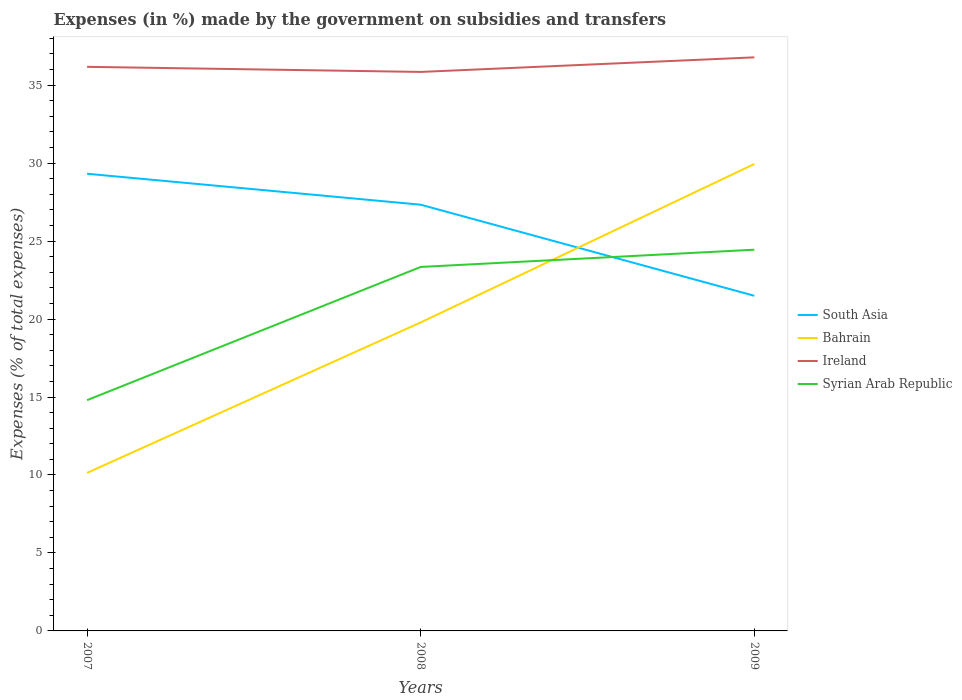Does the line corresponding to Ireland intersect with the line corresponding to South Asia?
Your response must be concise. No. Across all years, what is the maximum percentage of expenses made by the government on subsidies and transfers in Bahrain?
Make the answer very short. 10.14. In which year was the percentage of expenses made by the government on subsidies and transfers in Syrian Arab Republic maximum?
Your answer should be compact. 2007. What is the total percentage of expenses made by the government on subsidies and transfers in South Asia in the graph?
Your answer should be compact. 1.98. What is the difference between the highest and the second highest percentage of expenses made by the government on subsidies and transfers in Ireland?
Provide a short and direct response. 0.93. What is the difference between the highest and the lowest percentage of expenses made by the government on subsidies and transfers in Syrian Arab Republic?
Keep it short and to the point. 2. How many years are there in the graph?
Provide a succinct answer. 3. What is the difference between two consecutive major ticks on the Y-axis?
Your response must be concise. 5. Does the graph contain any zero values?
Your answer should be compact. No. How many legend labels are there?
Ensure brevity in your answer.  4. How are the legend labels stacked?
Provide a succinct answer. Vertical. What is the title of the graph?
Make the answer very short. Expenses (in %) made by the government on subsidies and transfers. Does "Dominican Republic" appear as one of the legend labels in the graph?
Keep it short and to the point. No. What is the label or title of the Y-axis?
Provide a short and direct response. Expenses (% of total expenses). What is the Expenses (% of total expenses) in South Asia in 2007?
Keep it short and to the point. 29.32. What is the Expenses (% of total expenses) of Bahrain in 2007?
Give a very brief answer. 10.14. What is the Expenses (% of total expenses) of Ireland in 2007?
Keep it short and to the point. 36.18. What is the Expenses (% of total expenses) in Syrian Arab Republic in 2007?
Provide a short and direct response. 14.8. What is the Expenses (% of total expenses) of South Asia in 2008?
Provide a short and direct response. 27.33. What is the Expenses (% of total expenses) in Bahrain in 2008?
Keep it short and to the point. 19.78. What is the Expenses (% of total expenses) of Ireland in 2008?
Make the answer very short. 35.85. What is the Expenses (% of total expenses) in Syrian Arab Republic in 2008?
Your response must be concise. 23.34. What is the Expenses (% of total expenses) of South Asia in 2009?
Offer a terse response. 21.49. What is the Expenses (% of total expenses) in Bahrain in 2009?
Give a very brief answer. 29.94. What is the Expenses (% of total expenses) of Ireland in 2009?
Your answer should be compact. 36.78. What is the Expenses (% of total expenses) in Syrian Arab Republic in 2009?
Your response must be concise. 24.45. Across all years, what is the maximum Expenses (% of total expenses) in South Asia?
Keep it short and to the point. 29.32. Across all years, what is the maximum Expenses (% of total expenses) of Bahrain?
Offer a terse response. 29.94. Across all years, what is the maximum Expenses (% of total expenses) of Ireland?
Your answer should be very brief. 36.78. Across all years, what is the maximum Expenses (% of total expenses) in Syrian Arab Republic?
Make the answer very short. 24.45. Across all years, what is the minimum Expenses (% of total expenses) in South Asia?
Provide a short and direct response. 21.49. Across all years, what is the minimum Expenses (% of total expenses) in Bahrain?
Provide a succinct answer. 10.14. Across all years, what is the minimum Expenses (% of total expenses) in Ireland?
Offer a very short reply. 35.85. Across all years, what is the minimum Expenses (% of total expenses) in Syrian Arab Republic?
Your answer should be very brief. 14.8. What is the total Expenses (% of total expenses) of South Asia in the graph?
Offer a terse response. 78.15. What is the total Expenses (% of total expenses) in Bahrain in the graph?
Your response must be concise. 59.87. What is the total Expenses (% of total expenses) of Ireland in the graph?
Offer a terse response. 108.81. What is the total Expenses (% of total expenses) in Syrian Arab Republic in the graph?
Your answer should be compact. 62.59. What is the difference between the Expenses (% of total expenses) of South Asia in 2007 and that in 2008?
Offer a terse response. 1.98. What is the difference between the Expenses (% of total expenses) of Bahrain in 2007 and that in 2008?
Give a very brief answer. -9.65. What is the difference between the Expenses (% of total expenses) in Ireland in 2007 and that in 2008?
Ensure brevity in your answer.  0.33. What is the difference between the Expenses (% of total expenses) of Syrian Arab Republic in 2007 and that in 2008?
Keep it short and to the point. -8.54. What is the difference between the Expenses (% of total expenses) in South Asia in 2007 and that in 2009?
Your response must be concise. 7.83. What is the difference between the Expenses (% of total expenses) of Bahrain in 2007 and that in 2009?
Offer a very short reply. -19.81. What is the difference between the Expenses (% of total expenses) in Ireland in 2007 and that in 2009?
Offer a terse response. -0.61. What is the difference between the Expenses (% of total expenses) of Syrian Arab Republic in 2007 and that in 2009?
Provide a succinct answer. -9.65. What is the difference between the Expenses (% of total expenses) of South Asia in 2008 and that in 2009?
Your answer should be very brief. 5.84. What is the difference between the Expenses (% of total expenses) of Bahrain in 2008 and that in 2009?
Provide a succinct answer. -10.16. What is the difference between the Expenses (% of total expenses) of Ireland in 2008 and that in 2009?
Offer a terse response. -0.93. What is the difference between the Expenses (% of total expenses) of Syrian Arab Republic in 2008 and that in 2009?
Offer a very short reply. -1.11. What is the difference between the Expenses (% of total expenses) of South Asia in 2007 and the Expenses (% of total expenses) of Bahrain in 2008?
Your response must be concise. 9.53. What is the difference between the Expenses (% of total expenses) in South Asia in 2007 and the Expenses (% of total expenses) in Ireland in 2008?
Give a very brief answer. -6.53. What is the difference between the Expenses (% of total expenses) in South Asia in 2007 and the Expenses (% of total expenses) in Syrian Arab Republic in 2008?
Ensure brevity in your answer.  5.98. What is the difference between the Expenses (% of total expenses) of Bahrain in 2007 and the Expenses (% of total expenses) of Ireland in 2008?
Offer a terse response. -25.71. What is the difference between the Expenses (% of total expenses) of Bahrain in 2007 and the Expenses (% of total expenses) of Syrian Arab Republic in 2008?
Your answer should be compact. -13.21. What is the difference between the Expenses (% of total expenses) in Ireland in 2007 and the Expenses (% of total expenses) in Syrian Arab Republic in 2008?
Give a very brief answer. 12.83. What is the difference between the Expenses (% of total expenses) in South Asia in 2007 and the Expenses (% of total expenses) in Bahrain in 2009?
Make the answer very short. -0.62. What is the difference between the Expenses (% of total expenses) in South Asia in 2007 and the Expenses (% of total expenses) in Ireland in 2009?
Offer a terse response. -7.46. What is the difference between the Expenses (% of total expenses) of South Asia in 2007 and the Expenses (% of total expenses) of Syrian Arab Republic in 2009?
Offer a very short reply. 4.87. What is the difference between the Expenses (% of total expenses) in Bahrain in 2007 and the Expenses (% of total expenses) in Ireland in 2009?
Provide a succinct answer. -26.65. What is the difference between the Expenses (% of total expenses) of Bahrain in 2007 and the Expenses (% of total expenses) of Syrian Arab Republic in 2009?
Ensure brevity in your answer.  -14.31. What is the difference between the Expenses (% of total expenses) in Ireland in 2007 and the Expenses (% of total expenses) in Syrian Arab Republic in 2009?
Offer a very short reply. 11.73. What is the difference between the Expenses (% of total expenses) in South Asia in 2008 and the Expenses (% of total expenses) in Bahrain in 2009?
Keep it short and to the point. -2.61. What is the difference between the Expenses (% of total expenses) in South Asia in 2008 and the Expenses (% of total expenses) in Ireland in 2009?
Make the answer very short. -9.45. What is the difference between the Expenses (% of total expenses) in South Asia in 2008 and the Expenses (% of total expenses) in Syrian Arab Republic in 2009?
Offer a very short reply. 2.89. What is the difference between the Expenses (% of total expenses) in Bahrain in 2008 and the Expenses (% of total expenses) in Ireland in 2009?
Offer a very short reply. -17. What is the difference between the Expenses (% of total expenses) in Bahrain in 2008 and the Expenses (% of total expenses) in Syrian Arab Republic in 2009?
Make the answer very short. -4.66. What is the difference between the Expenses (% of total expenses) in Ireland in 2008 and the Expenses (% of total expenses) in Syrian Arab Republic in 2009?
Ensure brevity in your answer.  11.4. What is the average Expenses (% of total expenses) of South Asia per year?
Your response must be concise. 26.05. What is the average Expenses (% of total expenses) of Bahrain per year?
Your answer should be compact. 19.95. What is the average Expenses (% of total expenses) in Ireland per year?
Ensure brevity in your answer.  36.27. What is the average Expenses (% of total expenses) of Syrian Arab Republic per year?
Ensure brevity in your answer.  20.86. In the year 2007, what is the difference between the Expenses (% of total expenses) in South Asia and Expenses (% of total expenses) in Bahrain?
Keep it short and to the point. 19.18. In the year 2007, what is the difference between the Expenses (% of total expenses) of South Asia and Expenses (% of total expenses) of Ireland?
Provide a succinct answer. -6.86. In the year 2007, what is the difference between the Expenses (% of total expenses) in South Asia and Expenses (% of total expenses) in Syrian Arab Republic?
Ensure brevity in your answer.  14.52. In the year 2007, what is the difference between the Expenses (% of total expenses) in Bahrain and Expenses (% of total expenses) in Ireland?
Make the answer very short. -26.04. In the year 2007, what is the difference between the Expenses (% of total expenses) in Bahrain and Expenses (% of total expenses) in Syrian Arab Republic?
Your response must be concise. -4.66. In the year 2007, what is the difference between the Expenses (% of total expenses) in Ireland and Expenses (% of total expenses) in Syrian Arab Republic?
Your response must be concise. 21.38. In the year 2008, what is the difference between the Expenses (% of total expenses) of South Asia and Expenses (% of total expenses) of Bahrain?
Provide a succinct answer. 7.55. In the year 2008, what is the difference between the Expenses (% of total expenses) in South Asia and Expenses (% of total expenses) in Ireland?
Make the answer very short. -8.51. In the year 2008, what is the difference between the Expenses (% of total expenses) of South Asia and Expenses (% of total expenses) of Syrian Arab Republic?
Make the answer very short. 3.99. In the year 2008, what is the difference between the Expenses (% of total expenses) of Bahrain and Expenses (% of total expenses) of Ireland?
Offer a very short reply. -16.06. In the year 2008, what is the difference between the Expenses (% of total expenses) of Bahrain and Expenses (% of total expenses) of Syrian Arab Republic?
Offer a terse response. -3.56. In the year 2008, what is the difference between the Expenses (% of total expenses) in Ireland and Expenses (% of total expenses) in Syrian Arab Republic?
Provide a short and direct response. 12.51. In the year 2009, what is the difference between the Expenses (% of total expenses) in South Asia and Expenses (% of total expenses) in Bahrain?
Your response must be concise. -8.45. In the year 2009, what is the difference between the Expenses (% of total expenses) in South Asia and Expenses (% of total expenses) in Ireland?
Offer a terse response. -15.29. In the year 2009, what is the difference between the Expenses (% of total expenses) of South Asia and Expenses (% of total expenses) of Syrian Arab Republic?
Your response must be concise. -2.96. In the year 2009, what is the difference between the Expenses (% of total expenses) of Bahrain and Expenses (% of total expenses) of Ireland?
Keep it short and to the point. -6.84. In the year 2009, what is the difference between the Expenses (% of total expenses) of Bahrain and Expenses (% of total expenses) of Syrian Arab Republic?
Provide a short and direct response. 5.5. In the year 2009, what is the difference between the Expenses (% of total expenses) of Ireland and Expenses (% of total expenses) of Syrian Arab Republic?
Ensure brevity in your answer.  12.34. What is the ratio of the Expenses (% of total expenses) in South Asia in 2007 to that in 2008?
Offer a terse response. 1.07. What is the ratio of the Expenses (% of total expenses) of Bahrain in 2007 to that in 2008?
Provide a succinct answer. 0.51. What is the ratio of the Expenses (% of total expenses) of Ireland in 2007 to that in 2008?
Ensure brevity in your answer.  1.01. What is the ratio of the Expenses (% of total expenses) in Syrian Arab Republic in 2007 to that in 2008?
Your answer should be compact. 0.63. What is the ratio of the Expenses (% of total expenses) of South Asia in 2007 to that in 2009?
Keep it short and to the point. 1.36. What is the ratio of the Expenses (% of total expenses) of Bahrain in 2007 to that in 2009?
Keep it short and to the point. 0.34. What is the ratio of the Expenses (% of total expenses) of Ireland in 2007 to that in 2009?
Offer a terse response. 0.98. What is the ratio of the Expenses (% of total expenses) of Syrian Arab Republic in 2007 to that in 2009?
Make the answer very short. 0.61. What is the ratio of the Expenses (% of total expenses) in South Asia in 2008 to that in 2009?
Your answer should be compact. 1.27. What is the ratio of the Expenses (% of total expenses) in Bahrain in 2008 to that in 2009?
Provide a succinct answer. 0.66. What is the ratio of the Expenses (% of total expenses) of Ireland in 2008 to that in 2009?
Ensure brevity in your answer.  0.97. What is the ratio of the Expenses (% of total expenses) of Syrian Arab Republic in 2008 to that in 2009?
Offer a very short reply. 0.95. What is the difference between the highest and the second highest Expenses (% of total expenses) in South Asia?
Make the answer very short. 1.98. What is the difference between the highest and the second highest Expenses (% of total expenses) in Bahrain?
Your answer should be compact. 10.16. What is the difference between the highest and the second highest Expenses (% of total expenses) in Ireland?
Provide a succinct answer. 0.61. What is the difference between the highest and the second highest Expenses (% of total expenses) of Syrian Arab Republic?
Offer a very short reply. 1.11. What is the difference between the highest and the lowest Expenses (% of total expenses) of South Asia?
Offer a terse response. 7.83. What is the difference between the highest and the lowest Expenses (% of total expenses) of Bahrain?
Your answer should be very brief. 19.81. What is the difference between the highest and the lowest Expenses (% of total expenses) in Ireland?
Your response must be concise. 0.93. What is the difference between the highest and the lowest Expenses (% of total expenses) of Syrian Arab Republic?
Your answer should be very brief. 9.65. 